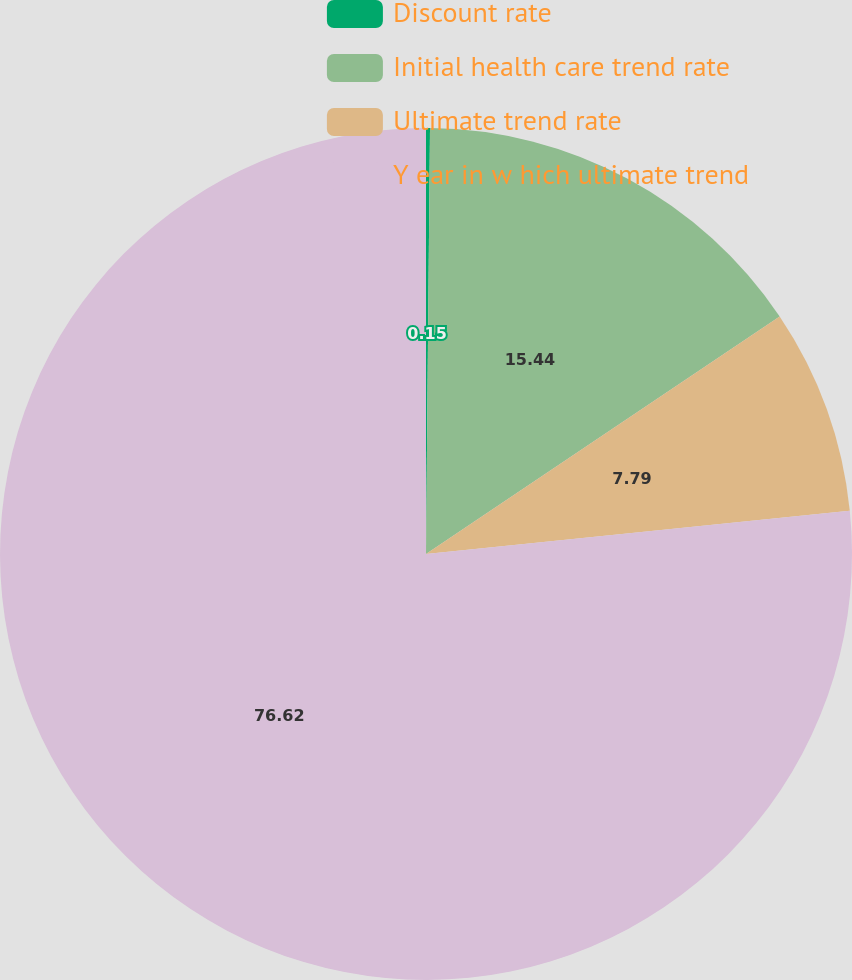Convert chart. <chart><loc_0><loc_0><loc_500><loc_500><pie_chart><fcel>Discount rate<fcel>Initial health care trend rate<fcel>Ultimate trend rate<fcel>Y ear in w hich ultimate trend<nl><fcel>0.15%<fcel>15.44%<fcel>7.79%<fcel>76.62%<nl></chart> 